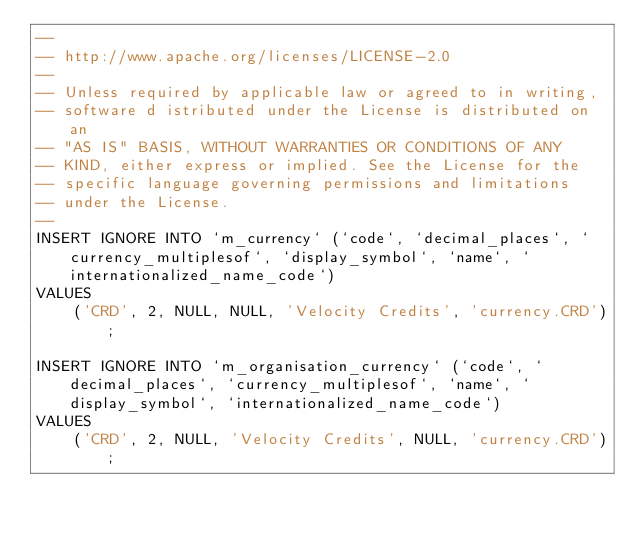<code> <loc_0><loc_0><loc_500><loc_500><_SQL_>--
-- http://www.apache.org/licenses/LICENSE-2.0
--
-- Unless required by applicable law or agreed to in writing,
-- software d istributed under the License is distributed on an
-- "AS IS" BASIS, WITHOUT WARRANTIES OR CONDITIONS OF ANY
-- KIND, either express or implied. See the License for the
-- specific language governing permissions and limitations
-- under the License.
--
INSERT IGNORE INTO `m_currency` (`code`, `decimal_places`, `currency_multiplesof`, `display_symbol`, `name`, `internationalized_name_code`)
VALUES
    ('CRD', 2, NULL, NULL, 'Velocity Credits', 'currency.CRD');

INSERT IGNORE INTO `m_organisation_currency` (`code`, `decimal_places`, `currency_multiplesof`, `name`, `display_symbol`, `internationalized_name_code`)
VALUES
    ('CRD', 2, NULL, 'Velocity Credits', NULL, 'currency.CRD');
</code> 